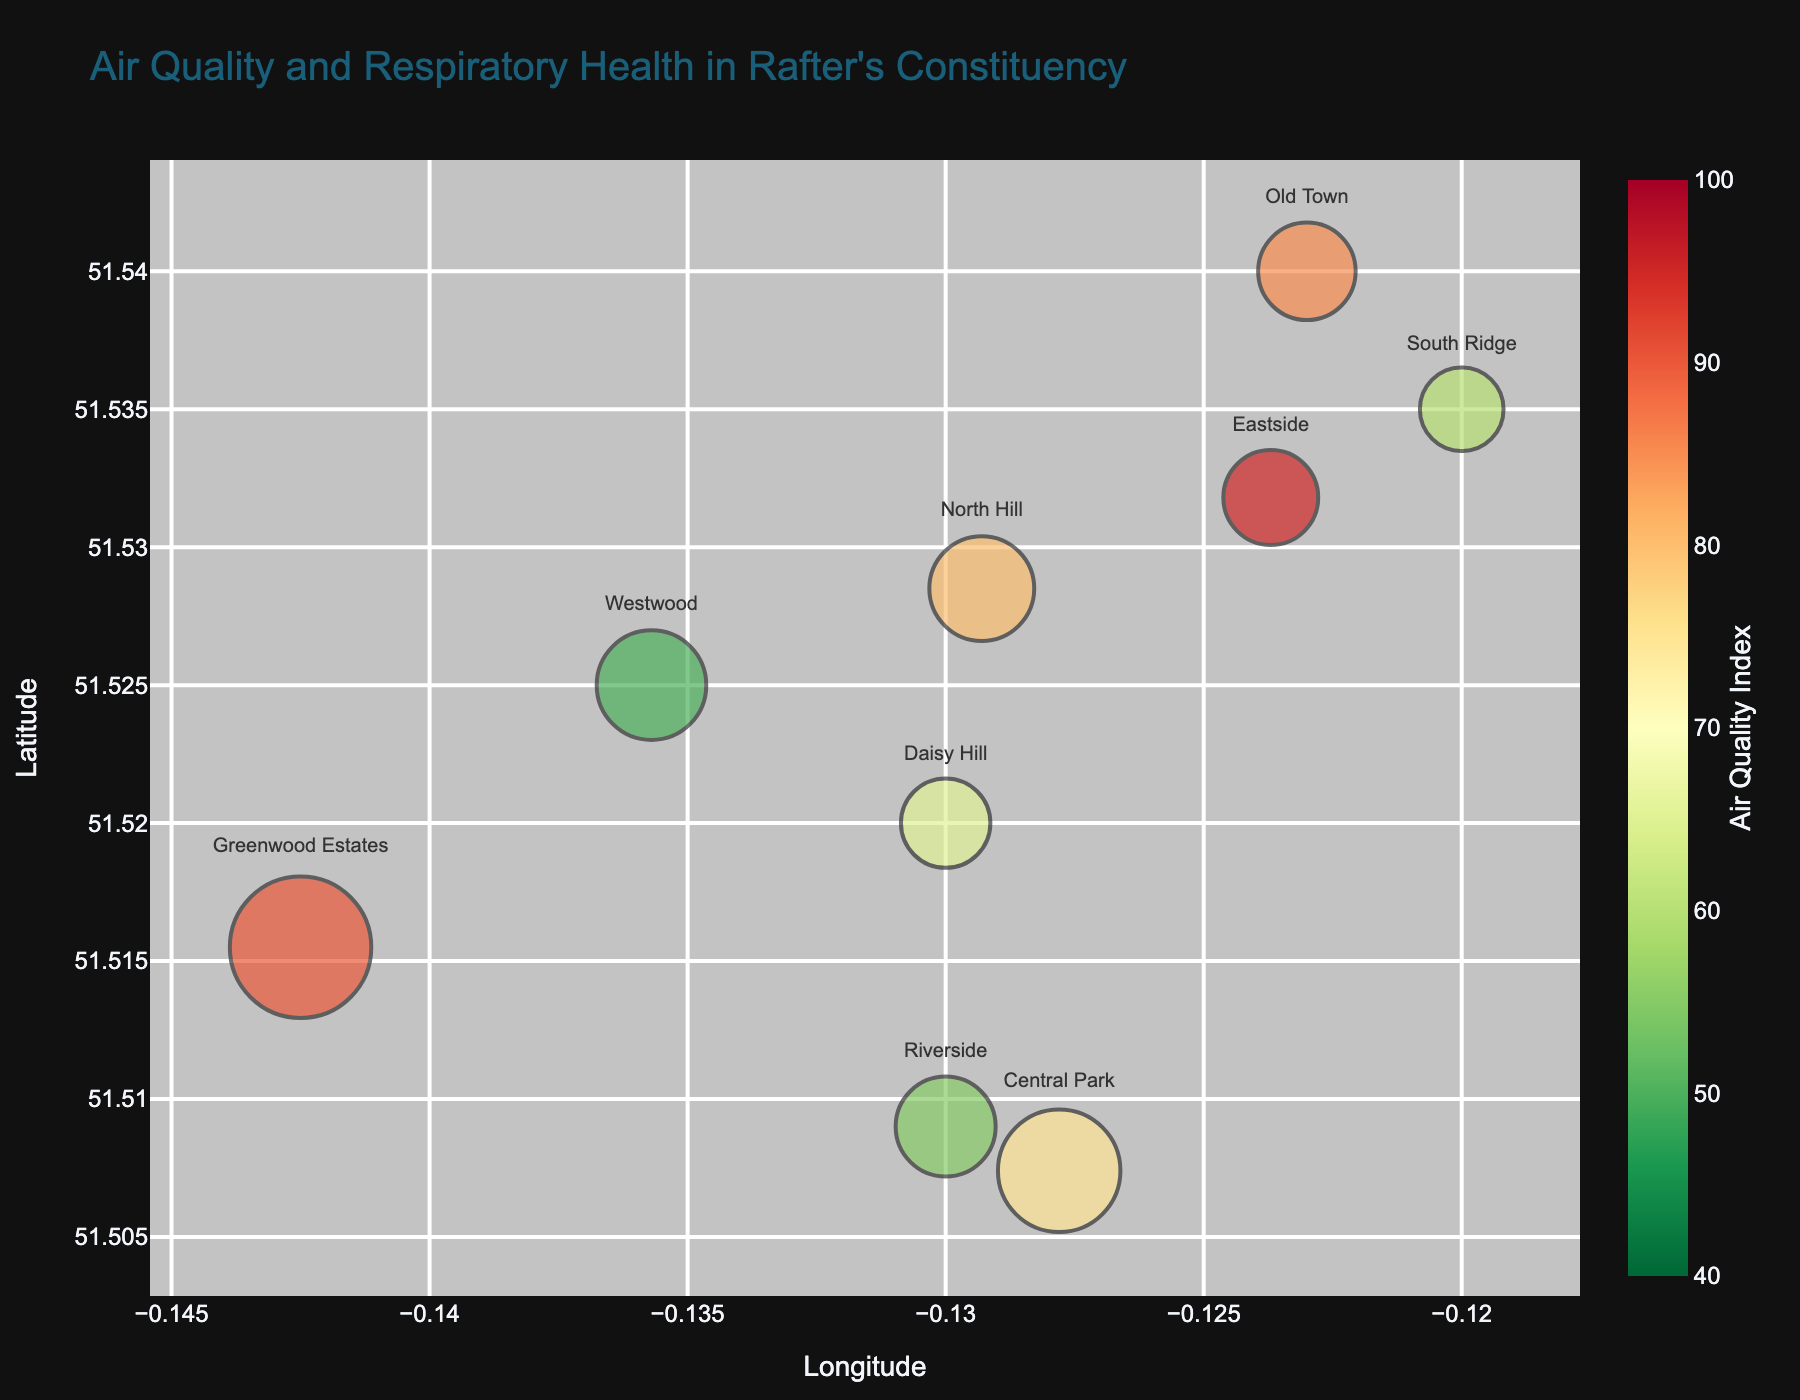What is the average AQI in Eastside? By looking at the location "Eastside" on the bubble chart and referring to the color-coding, we can see the label representing an AQI of 95 for Eastside.
Answer: 95 What are the X and Y axes representing in the bubble chart? The X-axis represents Longitude, and the Y-axis represents Latitude, which locates different areas within Rafter's constituency.
Answer: Longitude and Latitude Which location has the highest respiratory health issues per 1000 inhabitants? By examining the hover data over each bubble, the location "Eastside" has the highest value at 115 respiratory health issues per 1000 inhabitants.
Answer: Eastside How does the size of the bubble affect what we observe on the chart? The size of the bubble represents the population of each region; larger bubbles indicate areas with higher populations.
Answer: Population Which location has the lowest average AQI and what is its population? The lowest average AQI is at "Westwood," with an AQI of 50. The population of Westwood is 12,000.
Answer: Westwood, 12,000 Between Central Park and Greenwood Estates, which has a higher rate of respiratory health issues per 1000 inhabitants? Greenwood Estates has 110 respiratory health issues per 1000 inhabitants, higher than Central Park's 80, as indicated by the chart's hover data.
Answer: Greenwood Estates Is there a relationship between the average AQI and the respiratory health issues per 1000 inhabitants based on the chart? Yes, regions with higher AQI generally show higher respiratory health issues, as observed from the coloring and hover data presenting AQI and health issues together.
Answer: Yes Which location is represented by the largest bubble on the chart? The largest bubble, indicating the highest population, belongs to "Greenwood Estates" with a population of 20,000 inhabitants.
Answer: Greenwood Estates Between Daisy Hill and Old Town, which has a better AQI? Daisy Hill has a better AQI with a value of 65 compared to Old Town's AQI of 85, as shown by the color gradient.
Answer: Daisy Hill Identify the range of AQI values used in the color scale on the chart. The range of AQI values used in the color scale extends from 40 to 100.
Answer: 40 to 100 